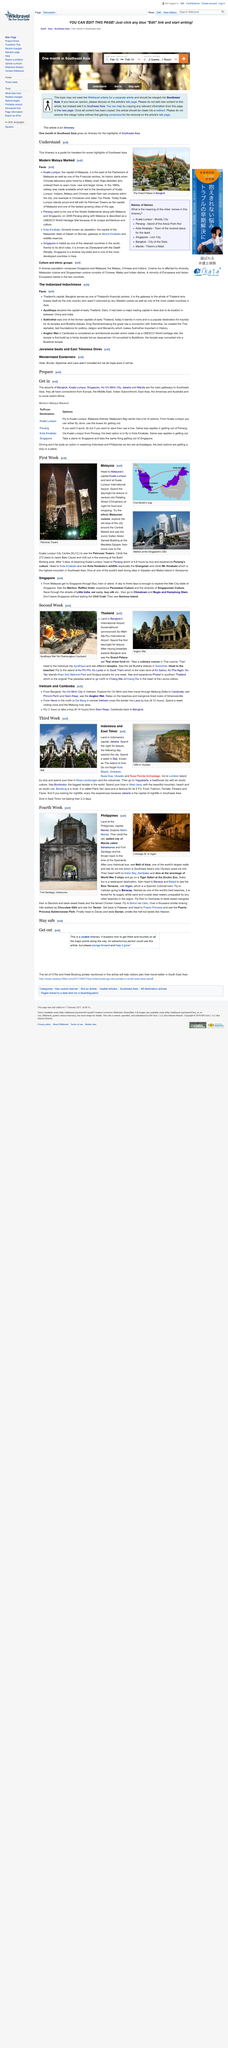Give some essential details in this illustration. The location in question is known as the Uluwatu Cliffs. Bali is also known as The Island of God. Mall of Asia is one of the world's largest malls, offering its visitors a vast array of shopping, dining, and entertainment options. According to the article "Modern Malaya Marked," the capital of Malaysia is Kuala Lumpur. Early Thailand had several former capitals, one of which was Sukhothai. 